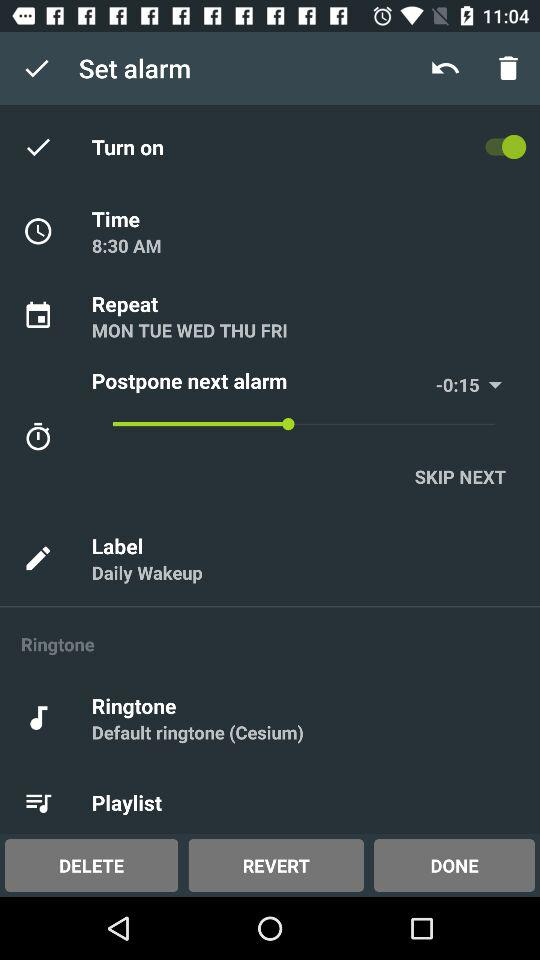What ringtone is selected? The selected ringtone is "Default ringtone(Cesium)". 